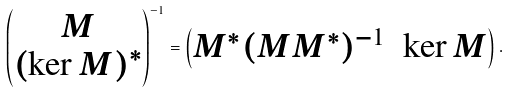<formula> <loc_0><loc_0><loc_500><loc_500>\begin{pmatrix} M \\ ( \ker M ) ^ { * } \end{pmatrix} ^ { - 1 } = \begin{pmatrix} M ^ { * } ( M M ^ { * } ) ^ { - 1 } & \ker M \end{pmatrix} .</formula> 